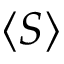Convert formula to latex. <formula><loc_0><loc_0><loc_500><loc_500>\left \langle { S } \right \rangle</formula> 